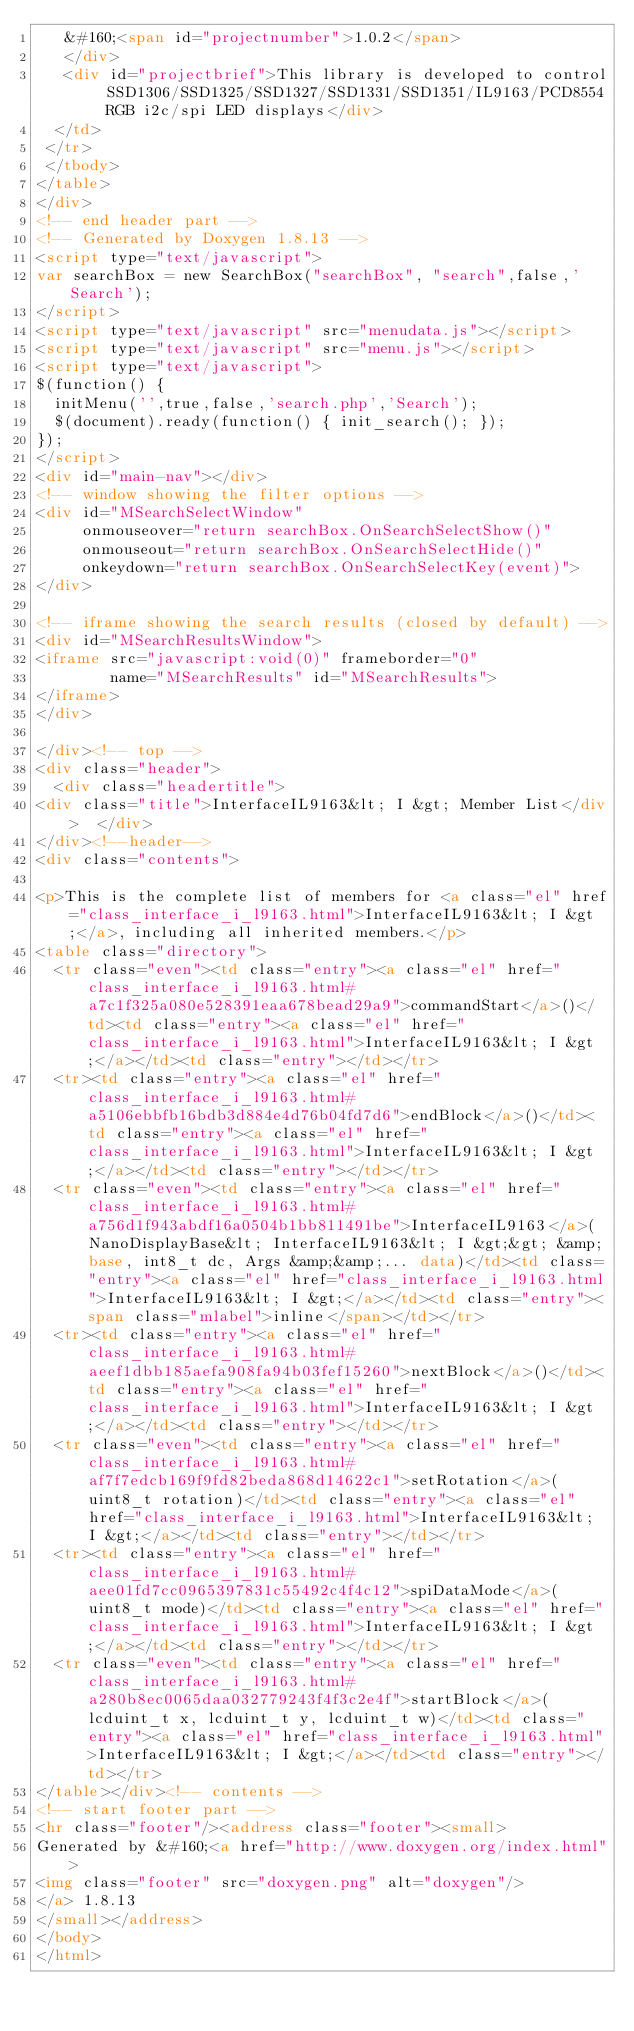Convert code to text. <code><loc_0><loc_0><loc_500><loc_500><_HTML_>   &#160;<span id="projectnumber">1.0.2</span>
   </div>
   <div id="projectbrief">This library is developed to control SSD1306/SSD1325/SSD1327/SSD1331/SSD1351/IL9163/PCD8554 RGB i2c/spi LED displays</div>
  </td>
 </tr>
 </tbody>
</table>
</div>
<!-- end header part -->
<!-- Generated by Doxygen 1.8.13 -->
<script type="text/javascript">
var searchBox = new SearchBox("searchBox", "search",false,'Search');
</script>
<script type="text/javascript" src="menudata.js"></script>
<script type="text/javascript" src="menu.js"></script>
<script type="text/javascript">
$(function() {
  initMenu('',true,false,'search.php','Search');
  $(document).ready(function() { init_search(); });
});
</script>
<div id="main-nav"></div>
<!-- window showing the filter options -->
<div id="MSearchSelectWindow"
     onmouseover="return searchBox.OnSearchSelectShow()"
     onmouseout="return searchBox.OnSearchSelectHide()"
     onkeydown="return searchBox.OnSearchSelectKey(event)">
</div>

<!-- iframe showing the search results (closed by default) -->
<div id="MSearchResultsWindow">
<iframe src="javascript:void(0)" frameborder="0" 
        name="MSearchResults" id="MSearchResults">
</iframe>
</div>

</div><!-- top -->
<div class="header">
  <div class="headertitle">
<div class="title">InterfaceIL9163&lt; I &gt; Member List</div>  </div>
</div><!--header-->
<div class="contents">

<p>This is the complete list of members for <a class="el" href="class_interface_i_l9163.html">InterfaceIL9163&lt; I &gt;</a>, including all inherited members.</p>
<table class="directory">
  <tr class="even"><td class="entry"><a class="el" href="class_interface_i_l9163.html#a7c1f325a080e528391eaa678bead29a9">commandStart</a>()</td><td class="entry"><a class="el" href="class_interface_i_l9163.html">InterfaceIL9163&lt; I &gt;</a></td><td class="entry"></td></tr>
  <tr><td class="entry"><a class="el" href="class_interface_i_l9163.html#a5106ebbfb16bdb3d884e4d76b04fd7d6">endBlock</a>()</td><td class="entry"><a class="el" href="class_interface_i_l9163.html">InterfaceIL9163&lt; I &gt;</a></td><td class="entry"></td></tr>
  <tr class="even"><td class="entry"><a class="el" href="class_interface_i_l9163.html#a756d1f943abdf16a0504b1bb811491be">InterfaceIL9163</a>(NanoDisplayBase&lt; InterfaceIL9163&lt; I &gt;&gt; &amp;base, int8_t dc, Args &amp;&amp;... data)</td><td class="entry"><a class="el" href="class_interface_i_l9163.html">InterfaceIL9163&lt; I &gt;</a></td><td class="entry"><span class="mlabel">inline</span></td></tr>
  <tr><td class="entry"><a class="el" href="class_interface_i_l9163.html#aeef1dbb185aefa908fa94b03fef15260">nextBlock</a>()</td><td class="entry"><a class="el" href="class_interface_i_l9163.html">InterfaceIL9163&lt; I &gt;</a></td><td class="entry"></td></tr>
  <tr class="even"><td class="entry"><a class="el" href="class_interface_i_l9163.html#af7f7edcb169f9fd82beda868d14622c1">setRotation</a>(uint8_t rotation)</td><td class="entry"><a class="el" href="class_interface_i_l9163.html">InterfaceIL9163&lt; I &gt;</a></td><td class="entry"></td></tr>
  <tr><td class="entry"><a class="el" href="class_interface_i_l9163.html#aee01fd7cc0965397831c55492c4f4c12">spiDataMode</a>(uint8_t mode)</td><td class="entry"><a class="el" href="class_interface_i_l9163.html">InterfaceIL9163&lt; I &gt;</a></td><td class="entry"></td></tr>
  <tr class="even"><td class="entry"><a class="el" href="class_interface_i_l9163.html#a280b8ec0065daa032779243f4f3c2e4f">startBlock</a>(lcduint_t x, lcduint_t y, lcduint_t w)</td><td class="entry"><a class="el" href="class_interface_i_l9163.html">InterfaceIL9163&lt; I &gt;</a></td><td class="entry"></td></tr>
</table></div><!-- contents -->
<!-- start footer part -->
<hr class="footer"/><address class="footer"><small>
Generated by &#160;<a href="http://www.doxygen.org/index.html">
<img class="footer" src="doxygen.png" alt="doxygen"/>
</a> 1.8.13
</small></address>
</body>
</html>
</code> 